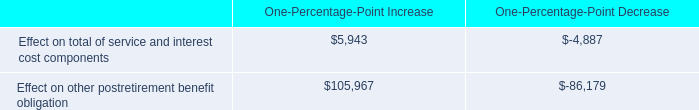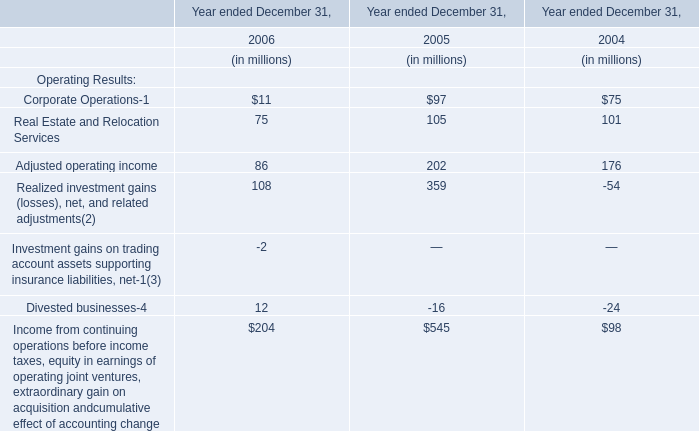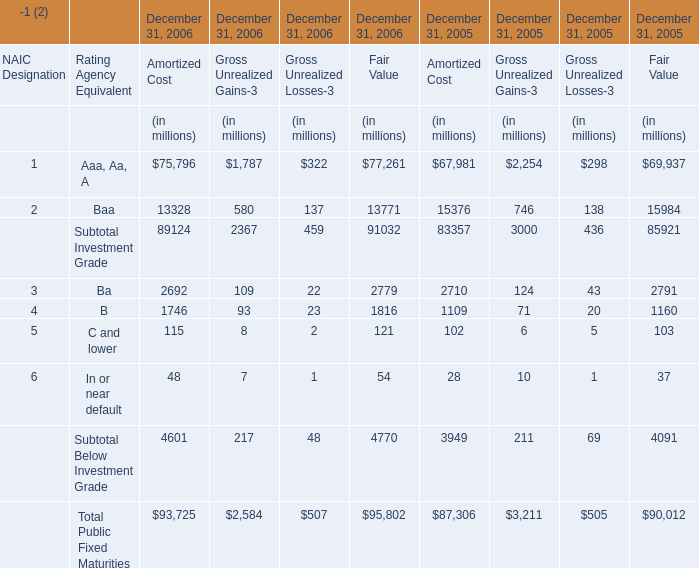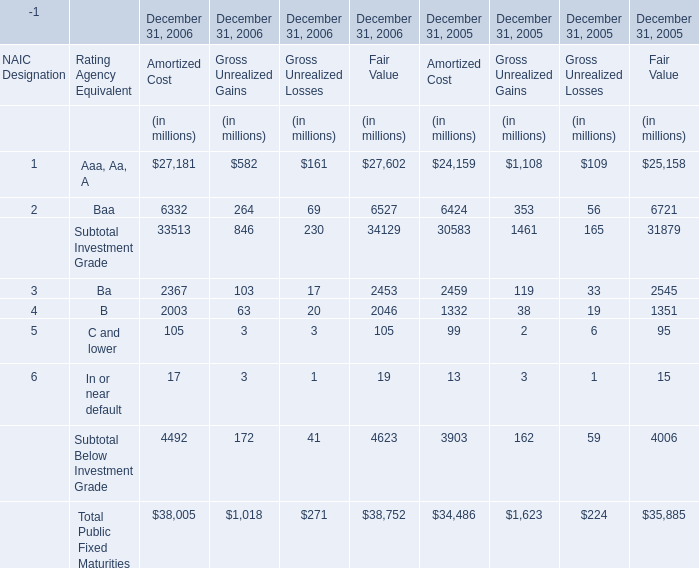What is the growing rate of Gross Unrealized Gains for Subtotal Investment Grade on December 31 between 2005 and 2006? 
Computations: ((846 - 1461) / 1461)
Answer: -0.42094. 